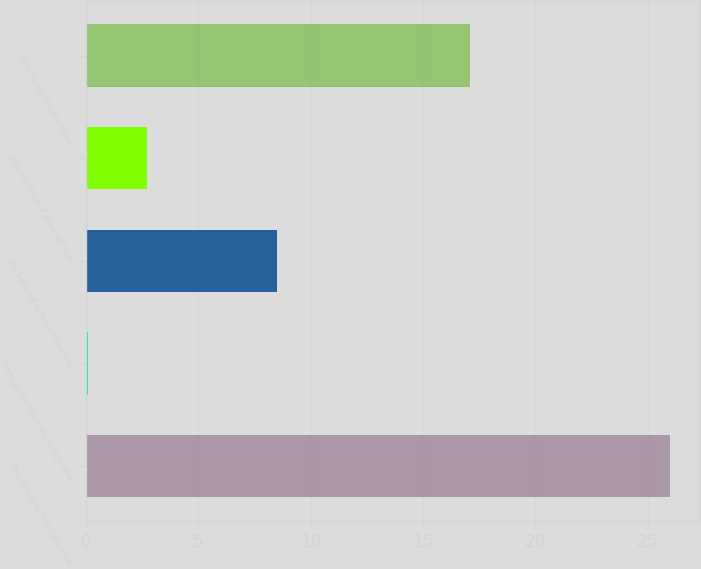Convert chart. <chart><loc_0><loc_0><loc_500><loc_500><bar_chart><fcel>Net actuarial loss (gain) net<fcel>Foreign currency exchange rate<fcel>Recognized actuarial loss net<fcel>Amortization of prior service<fcel>Total recognized in other<nl><fcel>26<fcel>0.1<fcel>8.5<fcel>2.69<fcel>17.1<nl></chart> 